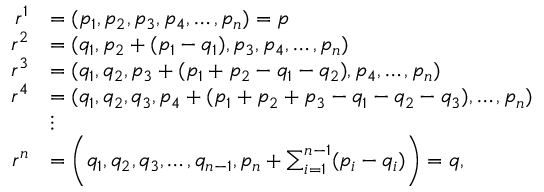Convert formula to latex. <formula><loc_0><loc_0><loc_500><loc_500>\begin{array} { r l } { r ^ { 1 } } & { = ( p _ { 1 } , p _ { 2 } , p _ { 3 } , p _ { 4 } , \dots , p _ { n } ) = p } \\ { r ^ { 2 } } & { = ( q _ { 1 } , p _ { 2 } + ( p _ { 1 } - q _ { 1 } ) , p _ { 3 } , p _ { 4 } , \dots , p _ { n } ) } \\ { r ^ { 3 } } & { = ( q _ { 1 } , q _ { 2 } , p _ { 3 } + ( p _ { 1 } + p _ { 2 } - q _ { 1 } - q _ { 2 } ) , p _ { 4 } , \dots , p _ { n } ) } \\ { r ^ { 4 } } & { = ( q _ { 1 } , q _ { 2 } , q _ { 3 } , p _ { 4 } + ( p _ { 1 } + p _ { 2 } + p _ { 3 } - q _ { 1 } - q _ { 2 } - q _ { 3 } ) , \dots , p _ { n } ) } \\ & { \vdots } \\ { r ^ { n } } & { = \left ( q _ { 1 } , q _ { 2 } , q _ { 3 } , \dots , q _ { n - 1 } , p _ { n } + \sum _ { i = 1 } ^ { n - 1 } ( p _ { i } - q _ { i } ) \right ) = q , } \end{array}</formula> 